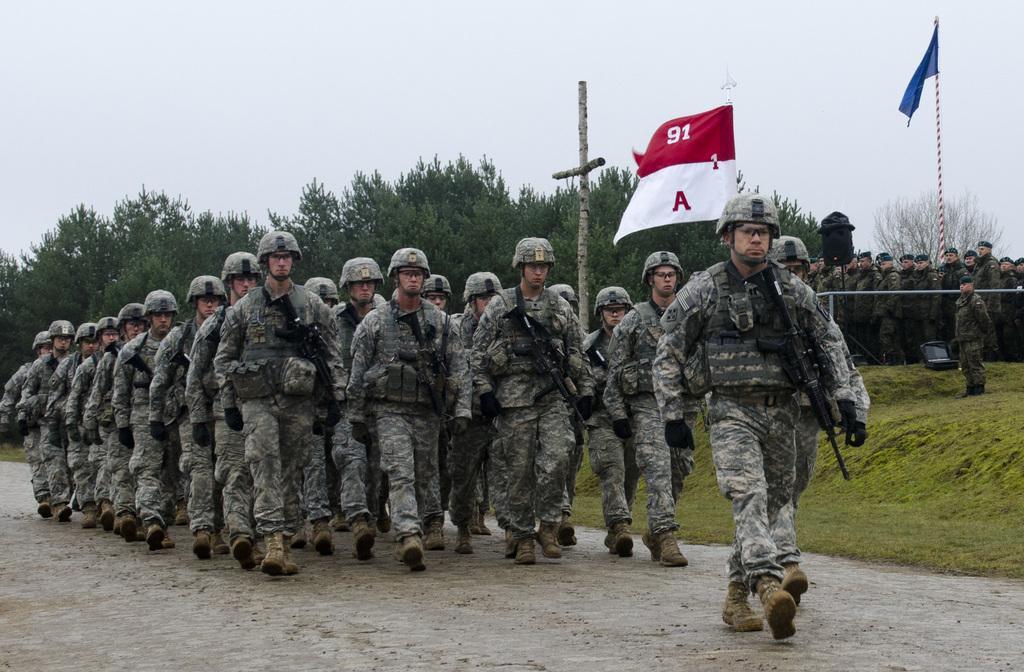How would you summarize this image in a sentence or two? In this image, we can see a few people. We can see the ground with some objects and some grass. We can see the fence and a pole. We can see a few flags and trees. We can see a black colored object and the sky. 